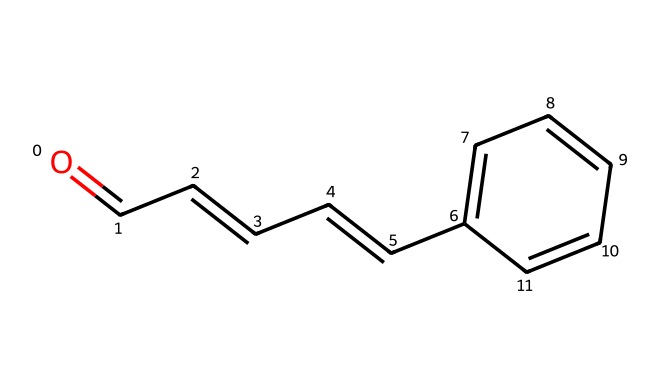What is the molecular formula of cinnamaldehyde? To determine the molecular formula, we can analyze the atoms present in the SMILES representation. Cinnamaldehyde contains 9 carbon (C) atoms, 8 hydrogen (H) atoms, and 1 oxygen (O) atom. Combining these gives the molecular formula C9H8O.
Answer: C9H8O How many rings are present in the structure of cinnamaldehyde? The SMILES representation indicates that there is a cyclic structure present (the ring is formed by the carbon atoms represented at the end). However, enumerating the structure visually confirms there is 1 ring.
Answer: 1 What functional group is associated with cinnamaldehyde? Analyzing the SMILES shows that there is a carbonyl group (C=O) at the beginning of the chain, which identifies cinnamaldehyde as an aldehyde due to the terminal carbonyl.
Answer: aldehyde How many double bonds are present in cinnamaldehyde? By examining the SMILES, we can see there are 3 double bonds in the structure: one in the carbonyl (C=O) and two in the carbon chain (C=C). Counting these gives a total of 3 double bonds.
Answer: 3 What is the significance of the carbonyl carbon in cinnamaldehyde? The carbonyl carbon, which is the carbon attached to the oxygen in the C=O group, is essential for its identity as an aldehyde and plays a key role in its reactivity and properties. It also directly affects the fragrance and flavor characteristics associated with cinnamon.
Answer: carbonyl What type of compound is cinnamaldehyde classified as? Analyzing the structure reveals the presence of an aldehyde group, which classifies cinnamaldehyde distinctly as an aldehyde due to its functional group, affecting its chemical characteristics and uses.
Answer: aldehyde 